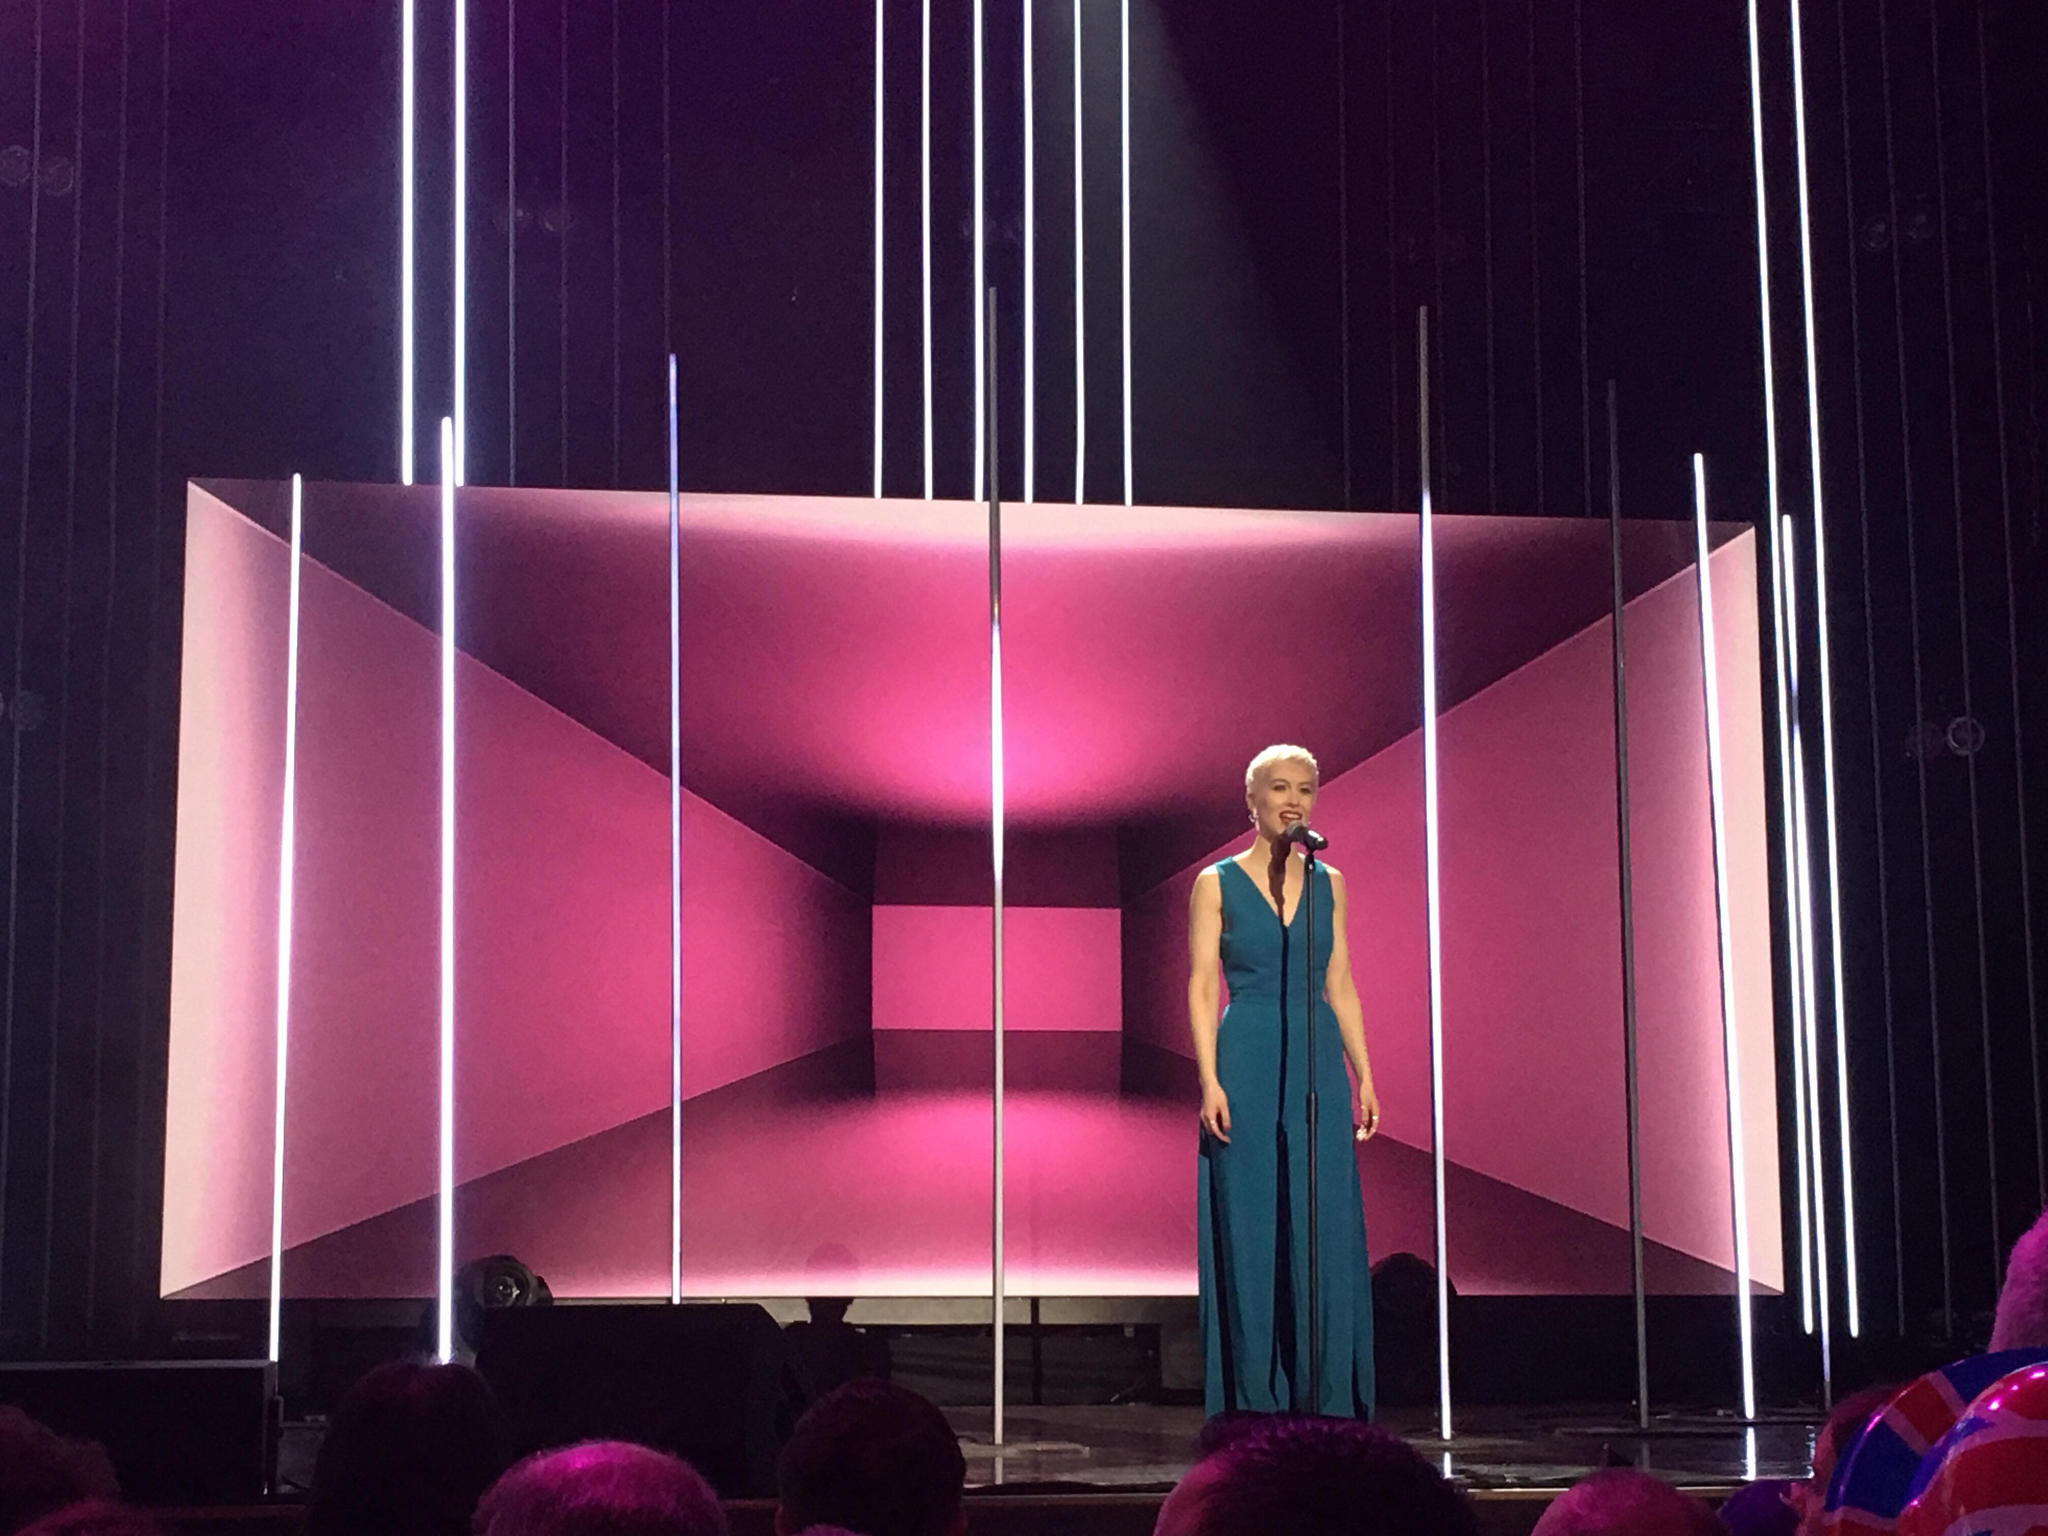Considering the stage design and lighting, what could be the theme or mood that the performance is trying to convey? Based on the geometric structure and the vertical white light beams, the stage design is likely aiming to convey a sense of modernity and sophistication. The use of pink and purple hues adds a touch of vibrancy and warmth, potentially suggesting a theme of passion, creativity, or emotional expression. The symmetry and order of the lights could indicate a structured, possibly dramatic performance. The overall mood appears to be one that combines energy with a polished, contemporary aesthetic. 